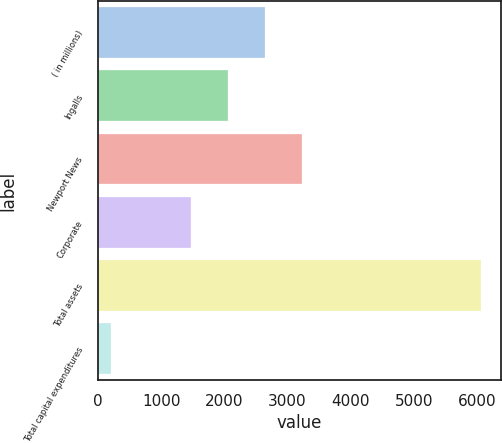Convert chart to OTSL. <chart><loc_0><loc_0><loc_500><loc_500><bar_chart><fcel>( in millions)<fcel>Ingalls<fcel>Newport News<fcel>Corporate<fcel>Total assets<fcel>Total capital expenditures<nl><fcel>2646.4<fcel>2059.2<fcel>3233.6<fcel>1472<fcel>6069<fcel>197<nl></chart> 